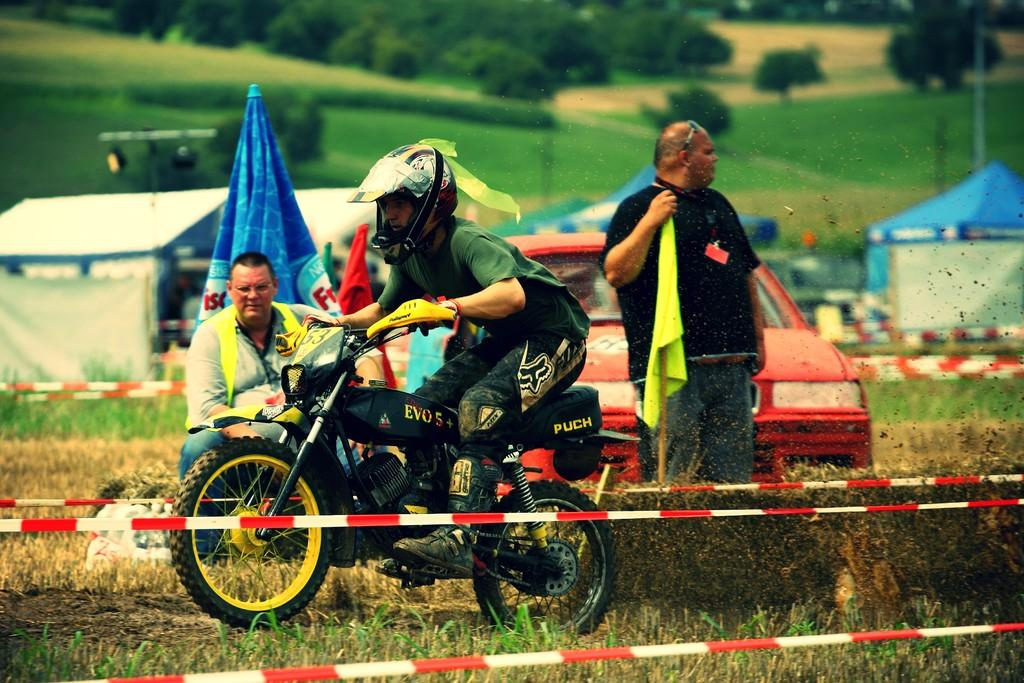What is the person in the foreground of the image doing? The person in the foreground is standing and holding a flag. Can you describe the position of the other people in the image? There is a person sitting and another person riding a bike and wearing a helmet. What can be seen in the background of the image? There are trees and tents in the background. What type of vehicle is visible in the image? There is a vehicle visible in the image. What type of reward can be seen being given to the person riding the bike in the image? There is no reward being given to the person riding the bike in the image. 